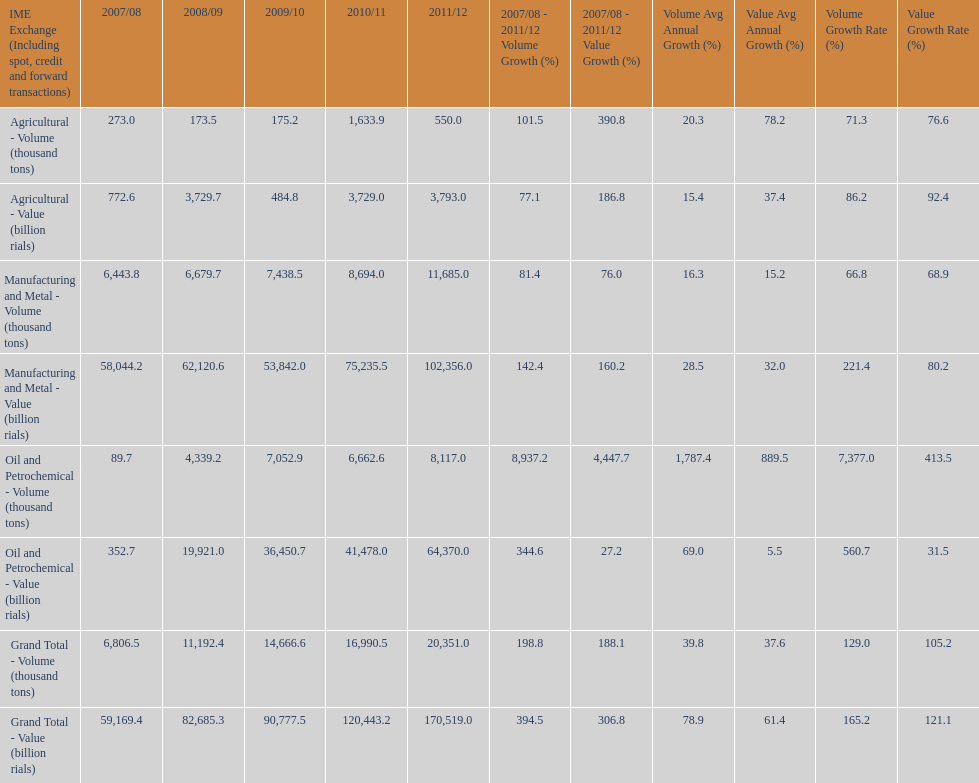In how many years was the value of agriculture, in billion rials, greater than 500 in iran? 4. 